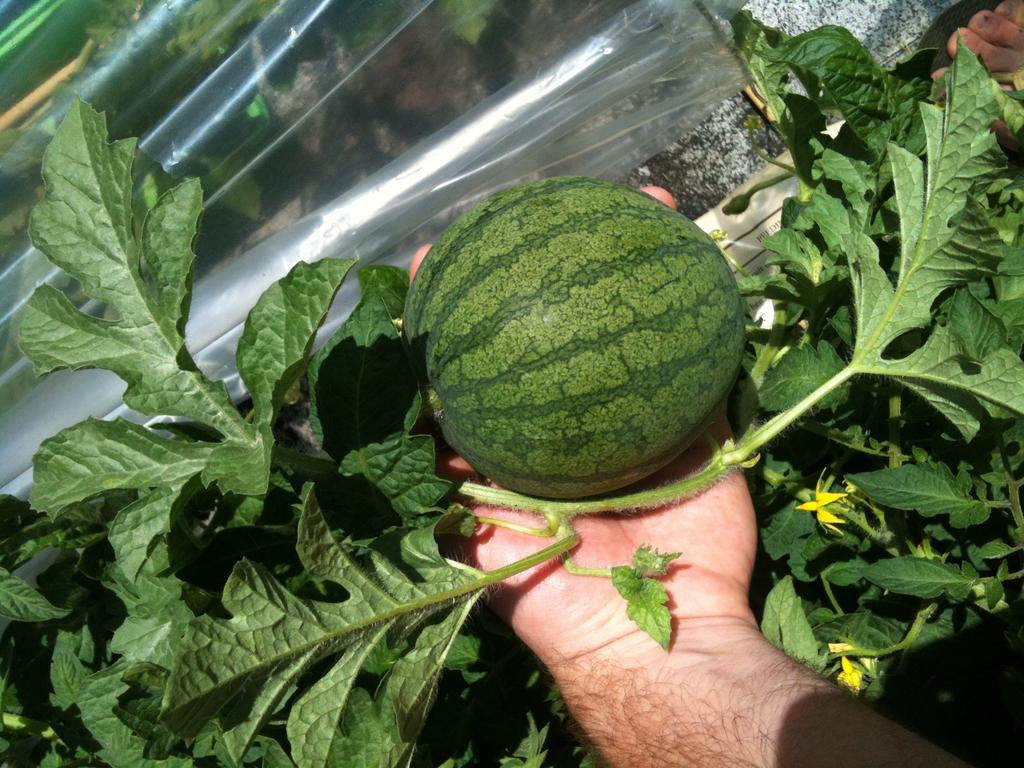What is the hand holding in the image? The hand is holding a fruit in the image. What can be seen behind the hand? There is a group of plants behind the hand. What is the transparent cover behind the fruit? There is a transparent cover behind the fruit. What type of sail can be seen in the cemetery in the image? There is no sail or cemetery present in the image; it features a hand holding a fruit with a group of plants and a transparent cover behind it. 